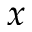<formula> <loc_0><loc_0><loc_500><loc_500>x</formula> 